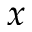<formula> <loc_0><loc_0><loc_500><loc_500>x</formula> 